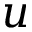<formula> <loc_0><loc_0><loc_500><loc_500>u</formula> 